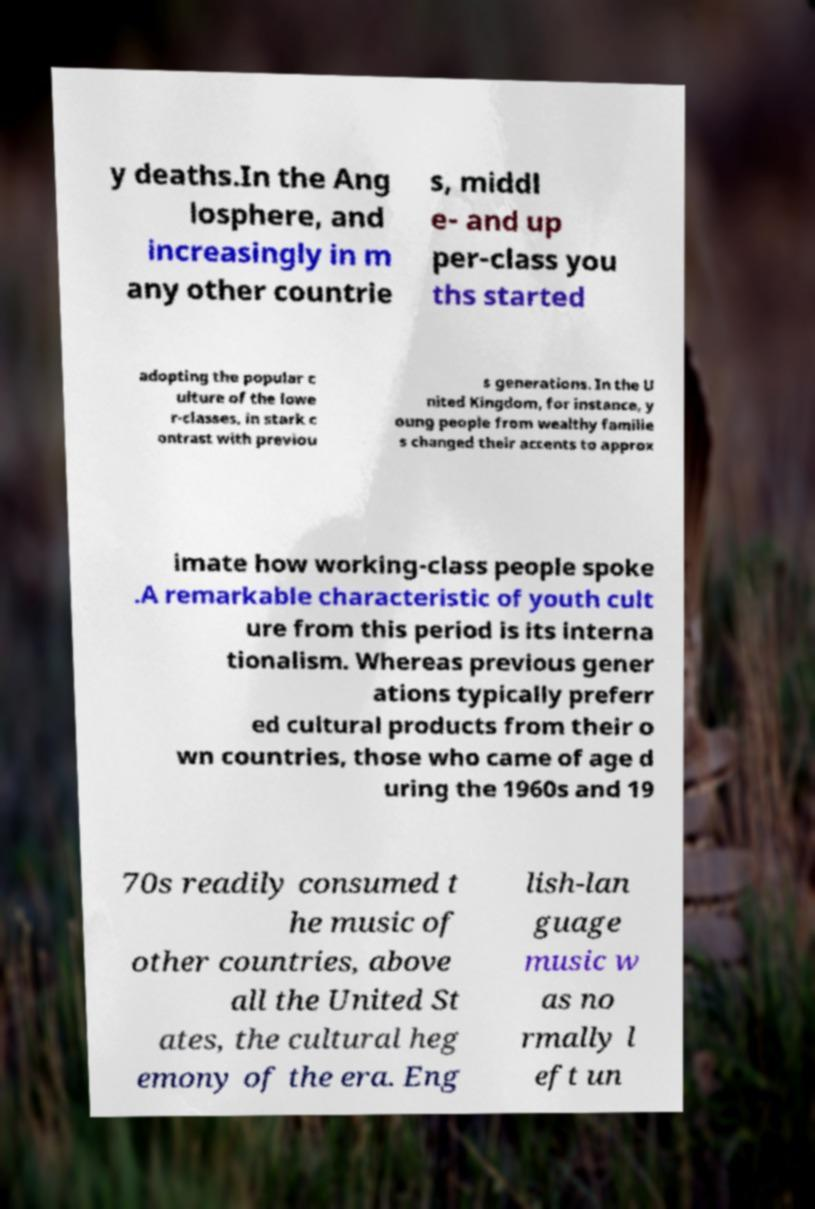Please read and relay the text visible in this image. What does it say? y deaths.In the Ang losphere, and increasingly in m any other countrie s, middl e- and up per-class you ths started adopting the popular c ulture of the lowe r-classes, in stark c ontrast with previou s generations. In the U nited Kingdom, for instance, y oung people from wealthy familie s changed their accents to approx imate how working-class people spoke .A remarkable characteristic of youth cult ure from this period is its interna tionalism. Whereas previous gener ations typically preferr ed cultural products from their o wn countries, those who came of age d uring the 1960s and 19 70s readily consumed t he music of other countries, above all the United St ates, the cultural heg emony of the era. Eng lish-lan guage music w as no rmally l eft un 